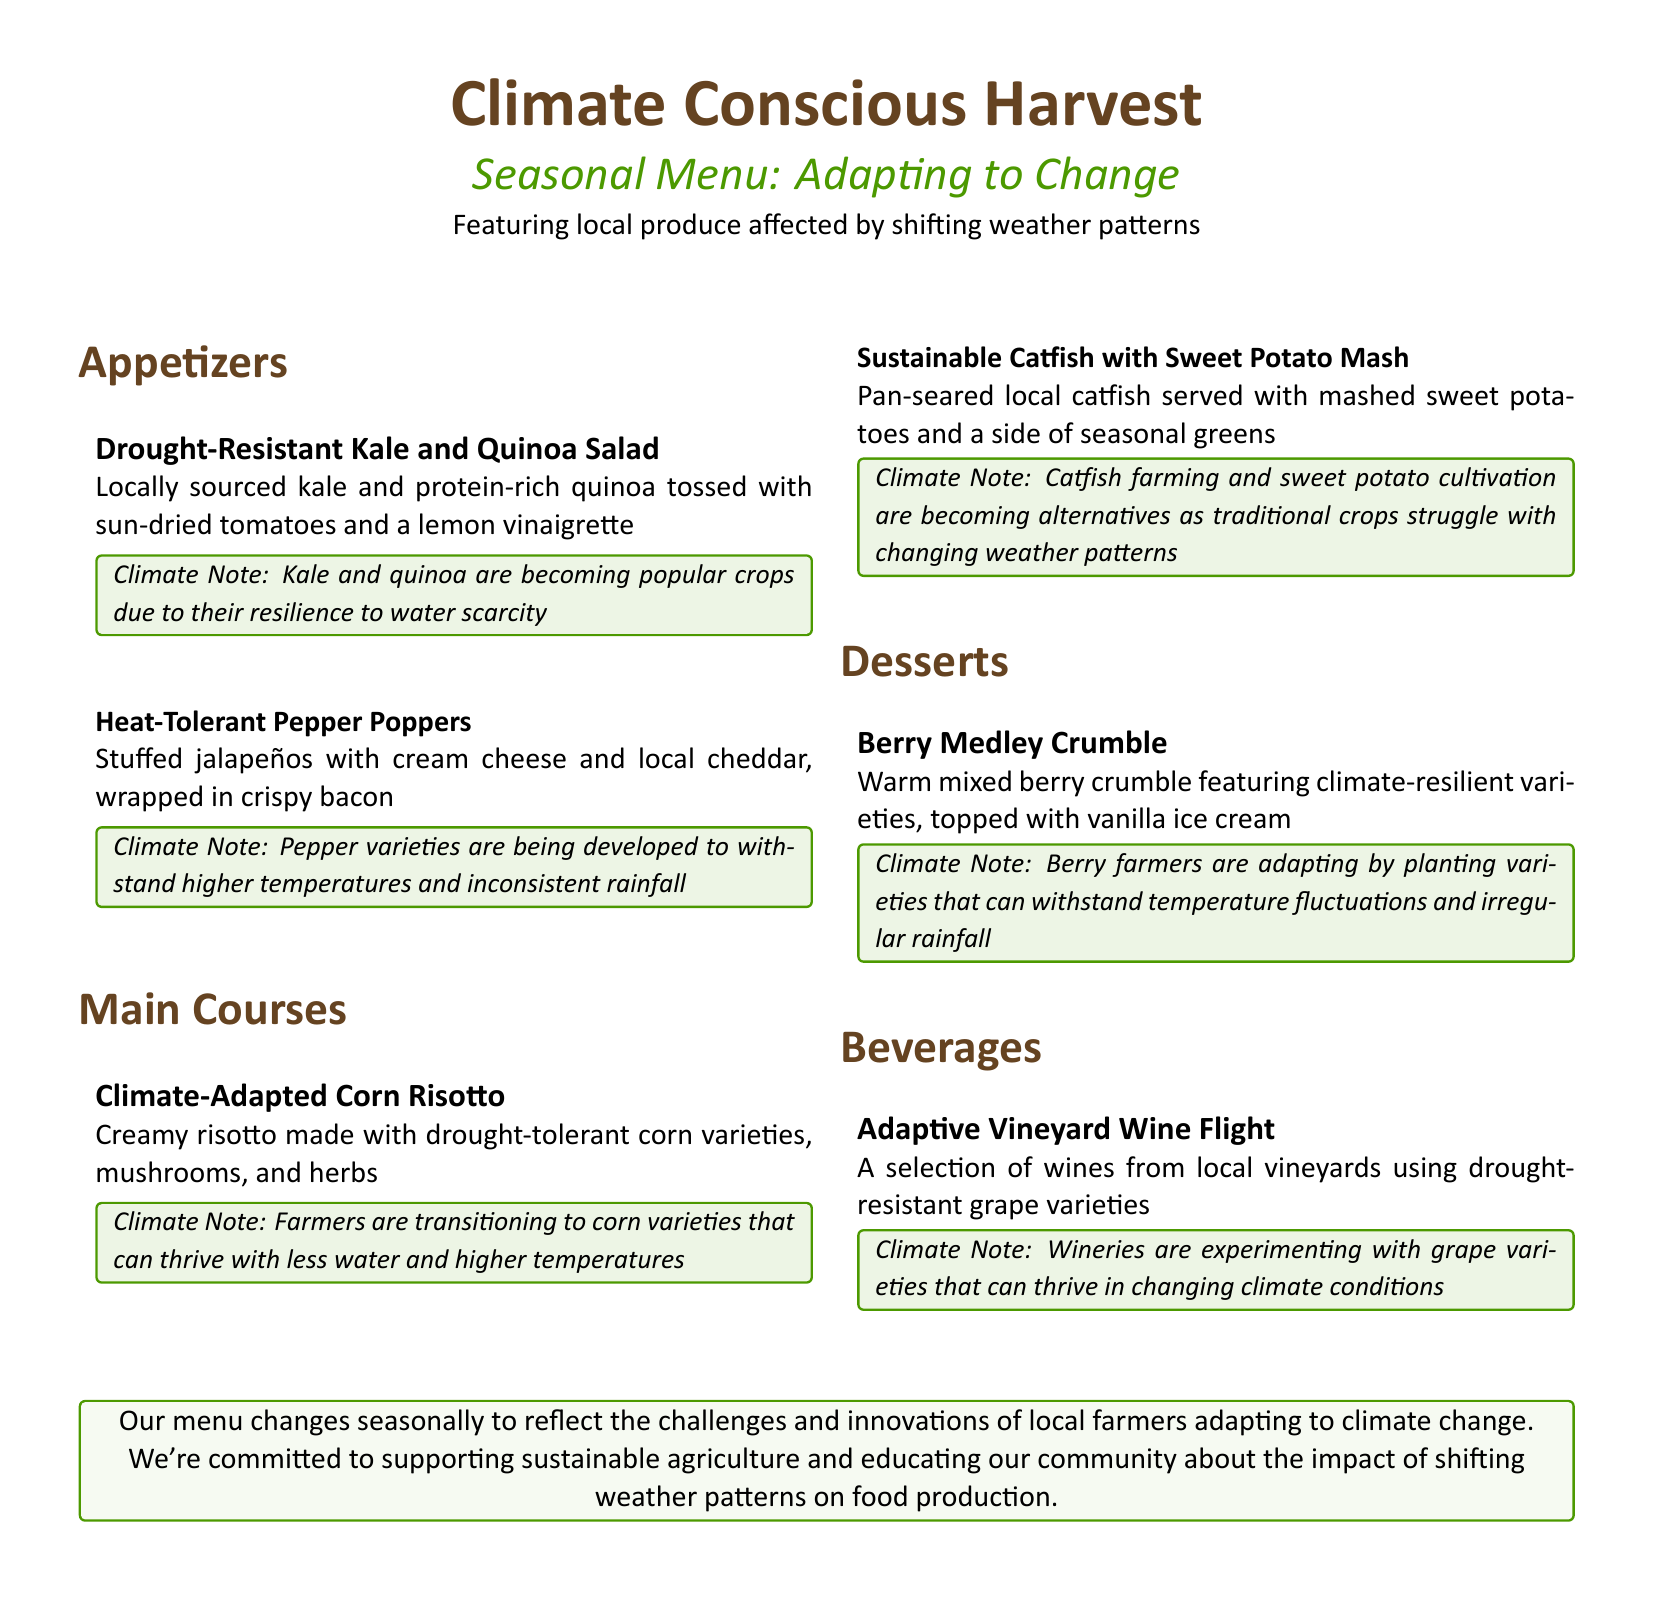What is the name of the first appetizer? The name of the first appetizer is listed at the top of the appetizers section of the menu.
Answer: Drought-Resistant Kale and Quinoa Salad How is the Climate-Adapted Corn Risotto made? The description provides details on the ingredients and preparation of this main course.
Answer: Made with drought-tolerant corn varieties, mushrooms, and herbs What dessert features climate-resilient varieties? The dessert item mentions the adaptation of the ingredients due to climate factors.
Answer: Berry Medley Crumble What beverage selection is available? The beverage section highlights a specific type of drink offered on the menu.
Answer: Adaptive Vineyard Wine Flight Why are farmers transitioning to specific corn varieties? This requires understanding the climate adaptation discussed in the menu section regarding corn.
Answer: To thrive with less water and higher temperatures How does this menu support local agriculture? The concluding note explains the commitment to local produce and sustainable practices.
Answer: Supports sustainable agriculture and educates the community What type of local fish is included in the main courses? This information can be found in the description of the second main course.
Answer: Catfish What color theme is used for the educational notes? This is based on the formatting used to highlight the educational notes throughout the document.
Answer: Earth green Which ingredient in the beverage is associated with drought resistance? This question pertains to the specific detail highlighted in the beverage section of the menu.
Answer: Grape varieties 